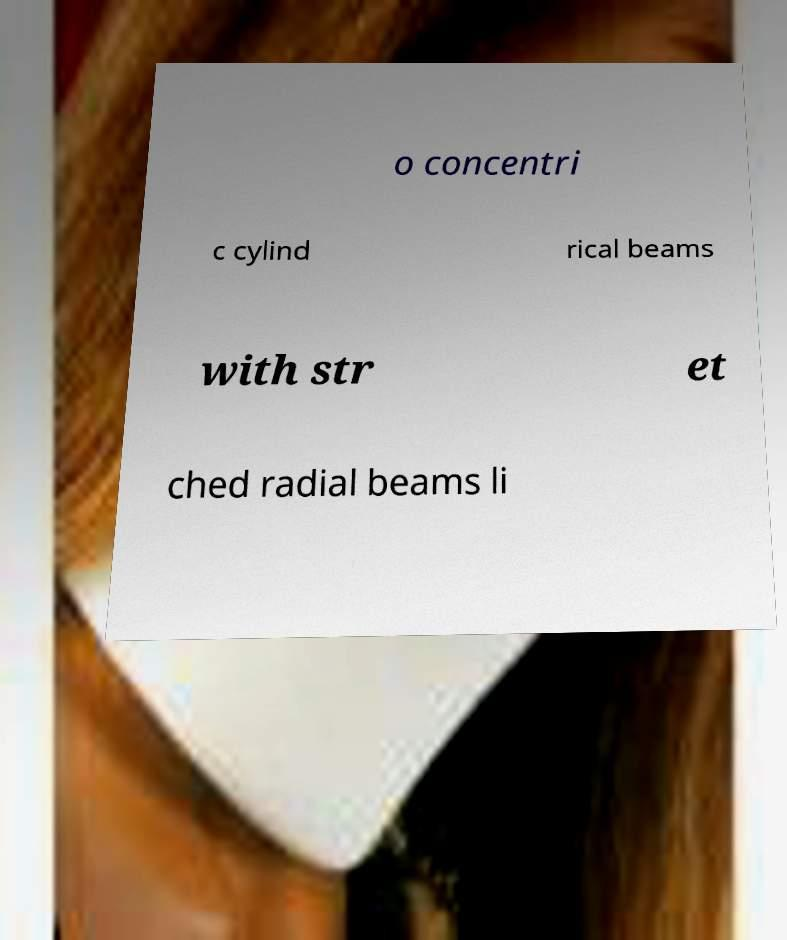There's text embedded in this image that I need extracted. Can you transcribe it verbatim? o concentri c cylind rical beams with str et ched radial beams li 